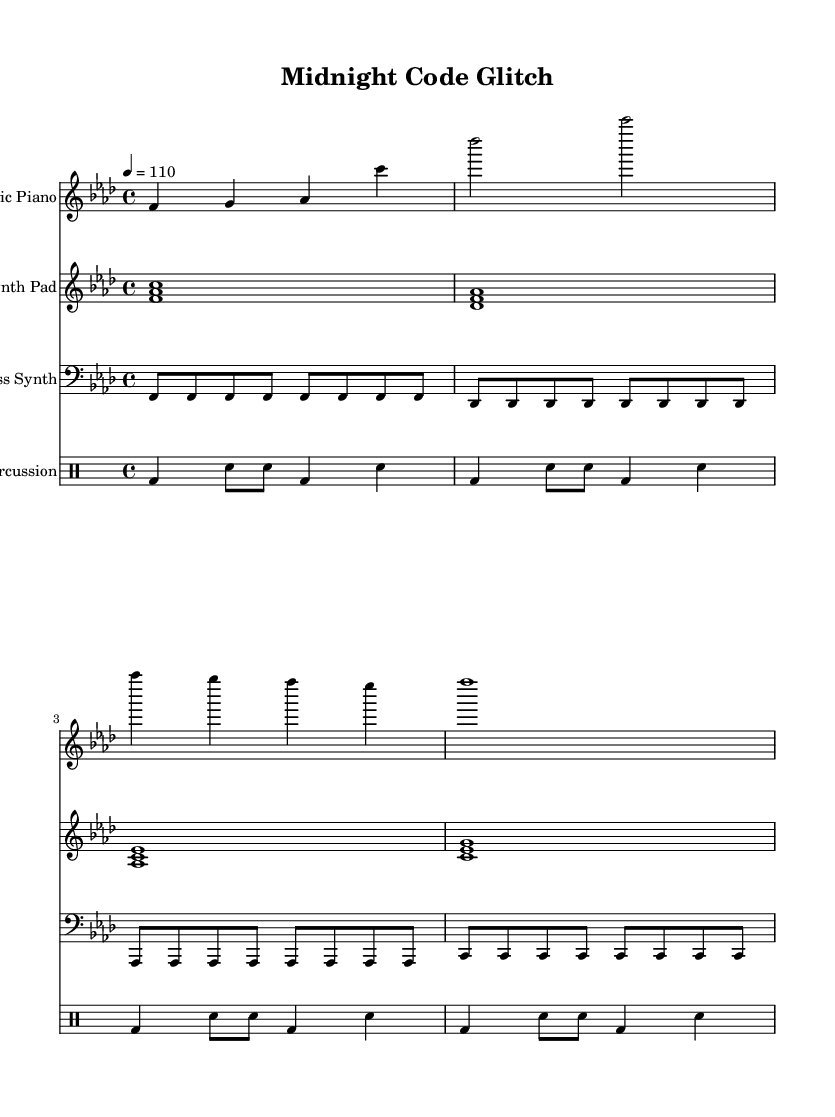What is the key signature of this music? The key signature indicates F minor, which has four flats (B, E, A, D). It's found at the beginning of the staff before the first note.
Answer: F minor What is the time signature of this piece? The time signature is found at the beginning of the score, which indicates 4 beats per measure. It is represented as 4/4.
Answer: 4/4 What is the tempo marking of the piece? The tempo marking, indicated at the beginning, shows that the piece should be played at 110 beats per minute, reflecting a moderate tempo.
Answer: 110 How many measures does the electric piano part contain? By counting the measures in the electric piano's staff, it shows a total of 4 measures.
Answer: 4 Which instrument is indicated for the bass part? The bass part is designated for the bass synth, which is identified by the clef used and its specific instrument name label.
Answer: Bass Synth What rhythmic pattern is used in the glitch percussion? The glitch percussion follows a repeated pattern that combines kick drum and snare hits in a regular 4/4 meter, specifically alternating between them.
Answer: Kick and snare How is the synth pad harmonically structured? The synth pad consists of harmonized chords played on the first beat of each measure, showcasing the selected root notes arranged in triads within the context of ambient dance.
Answer: Chords 